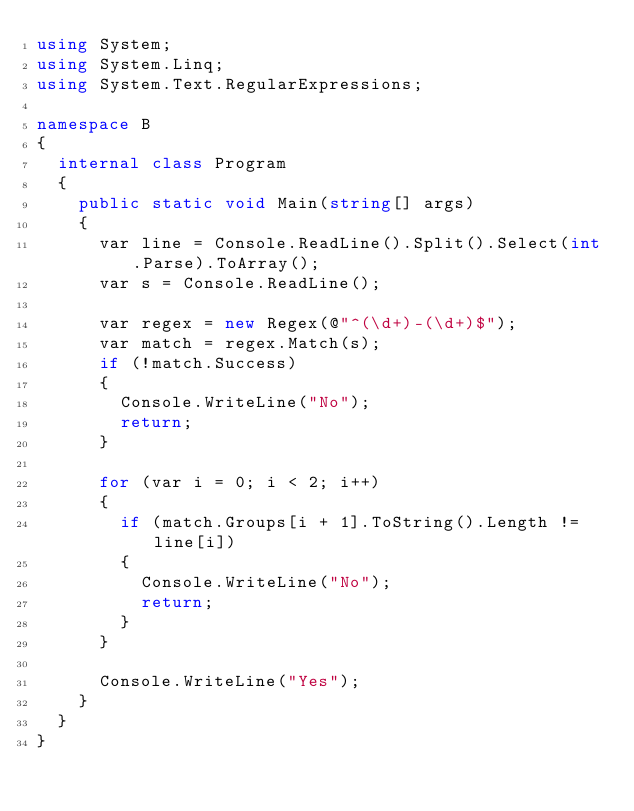Convert code to text. <code><loc_0><loc_0><loc_500><loc_500><_C#_>using System;
using System.Linq;
using System.Text.RegularExpressions;

namespace B
{
	internal class Program
	{
		public static void Main(string[] args)
		{
			var line = Console.ReadLine().Split().Select(int.Parse).ToArray();
			var s = Console.ReadLine();

			var regex = new Regex(@"^(\d+)-(\d+)$");
			var match = regex.Match(s);
			if (!match.Success)
			{
				Console.WriteLine("No");
				return;
			}

			for (var i = 0; i < 2; i++)
			{
				if (match.Groups[i + 1].ToString().Length != line[i])
				{
					Console.WriteLine("No");
					return;
				}
			}

			Console.WriteLine("Yes");
		}
	}
}</code> 